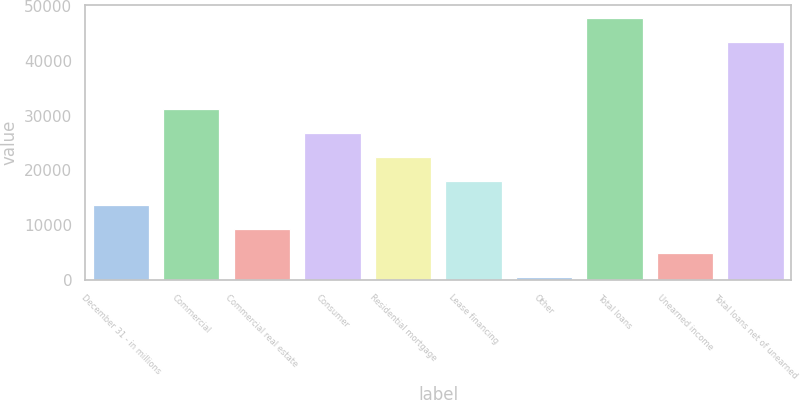Convert chart. <chart><loc_0><loc_0><loc_500><loc_500><bar_chart><fcel>December 31 - in millions<fcel>Commercial<fcel>Commercial real estate<fcel>Consumer<fcel>Residential mortgage<fcel>Lease financing<fcel>Other<fcel>Total loans<fcel>Unearned income<fcel>Total loans net of unearned<nl><fcel>13672.6<fcel>31229.4<fcel>9283.4<fcel>26840.2<fcel>22451<fcel>18061.8<fcel>505<fcel>47884.2<fcel>4894.2<fcel>43495<nl></chart> 